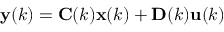<formula> <loc_0><loc_0><loc_500><loc_500>y ( k ) = C ( k ) x ( k ) + D ( k ) u ( k )</formula> 